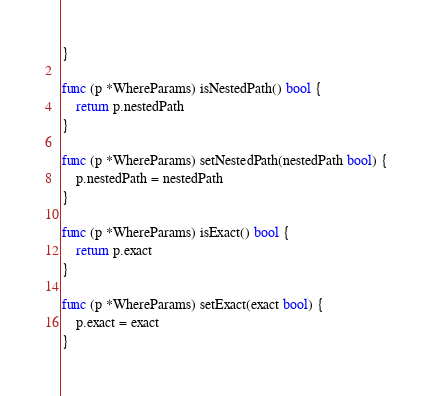<code> <loc_0><loc_0><loc_500><loc_500><_Go_>}

func (p *WhereParams) isNestedPath() bool {
	return p.nestedPath
}

func (p *WhereParams) setNestedPath(nestedPath bool) {
	p.nestedPath = nestedPath
}

func (p *WhereParams) isExact() bool {
	return p.exact
}

func (p *WhereParams) setExact(exact bool) {
	p.exact = exact
}
</code> 